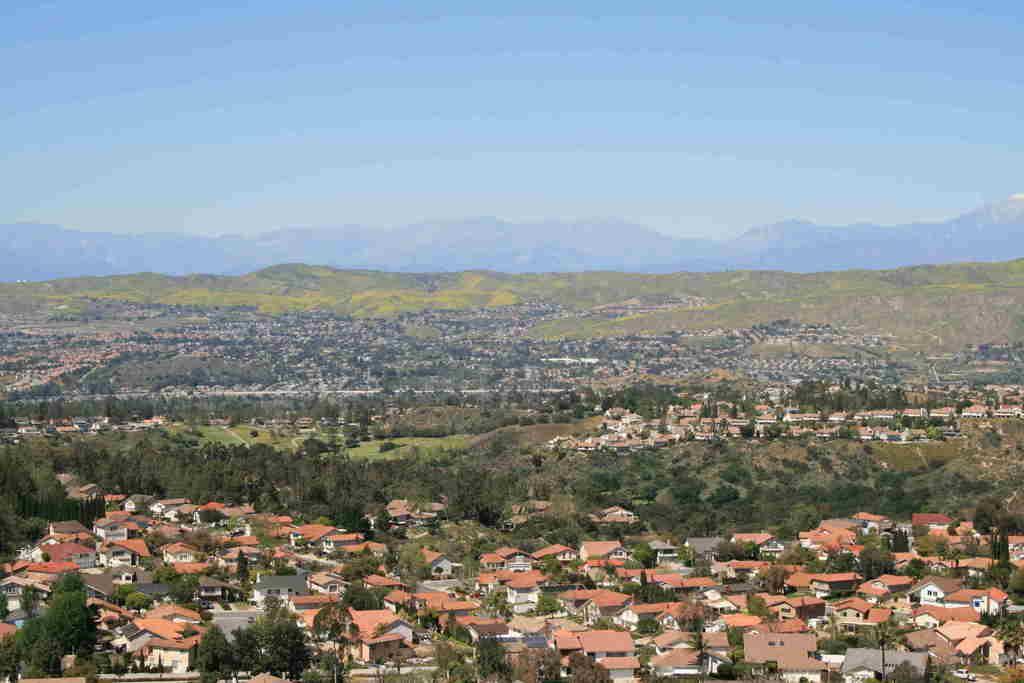Please provide a concise description of this image. In this picture we can see many houses and trees from left to right. Sky is blue in color. 